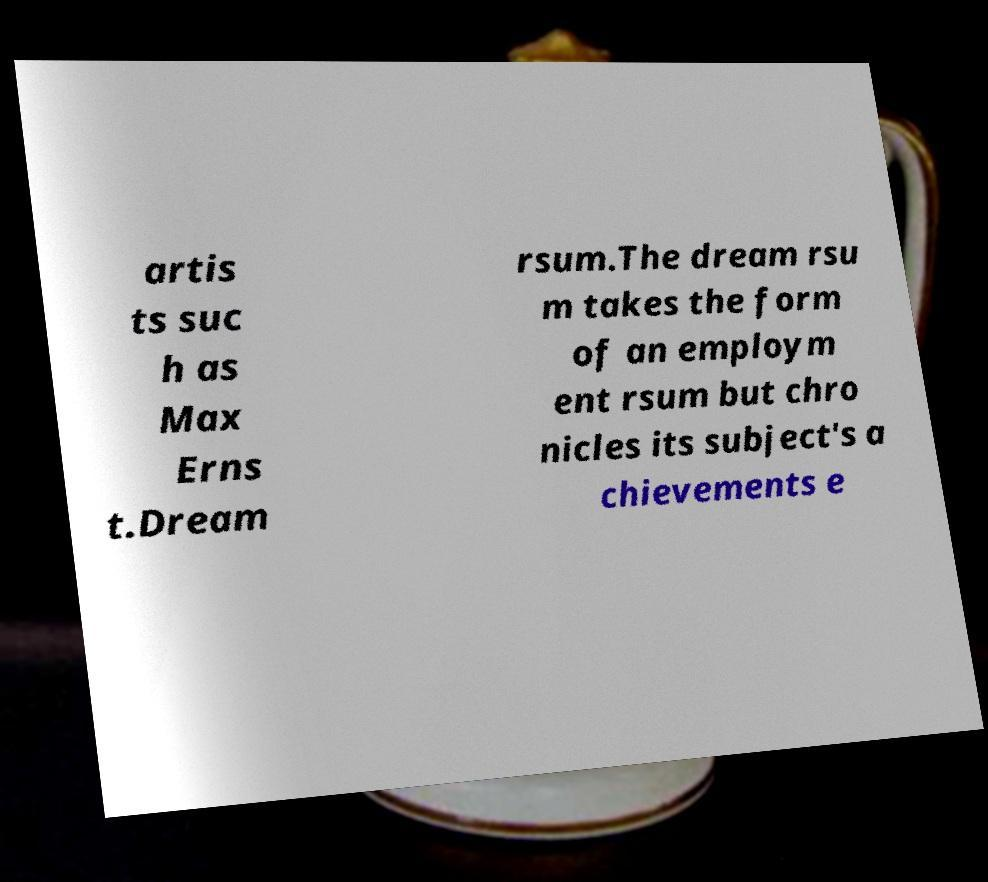Can you read and provide the text displayed in the image?This photo seems to have some interesting text. Can you extract and type it out for me? artis ts suc h as Max Erns t.Dream rsum.The dream rsu m takes the form of an employm ent rsum but chro nicles its subject's a chievements e 